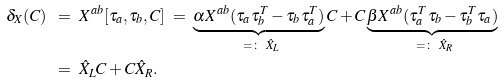Convert formula to latex. <formula><loc_0><loc_0><loc_500><loc_500>\delta _ { X } ( C ) \ & = \ X ^ { a b } [ \tau _ { a } , \tau _ { b } , C ] \ = \ \underbrace { \alpha X ^ { a b } ( \tau _ { a } \tau _ { b } ^ { T } - \tau _ { b } \tau _ { a } ^ { T } ) } _ { \ = \colon \ \hat { X } _ { L } } C + C \underbrace { \beta X ^ { a b } ( \tau _ { a } ^ { T } \tau _ { b } - \tau _ { b } ^ { T } \tau _ { a } ) } _ { \ = \colon \ \hat { X } _ { R } } \\ & = \ \hat { X } _ { L } C + C \hat { X } _ { R } .</formula> 